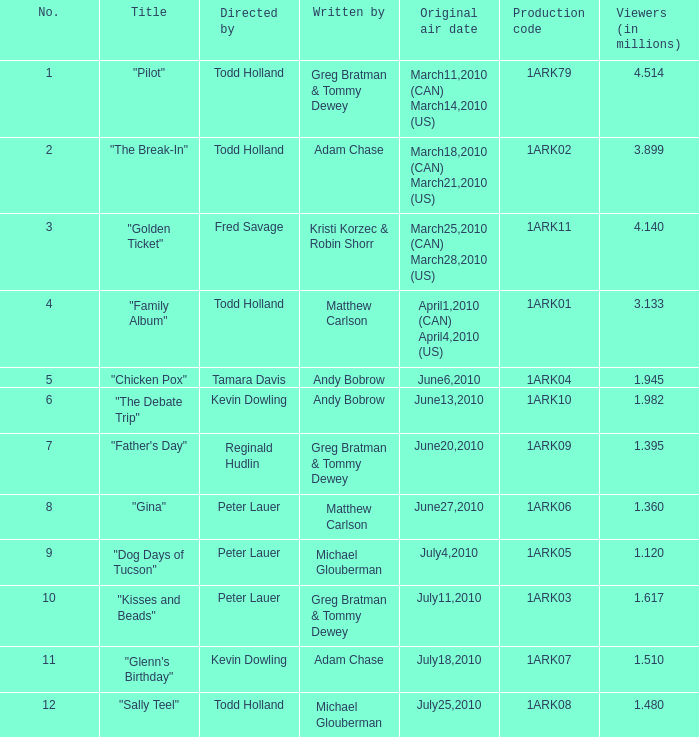List all who wrote for production code 1ark07. Adam Chase. 